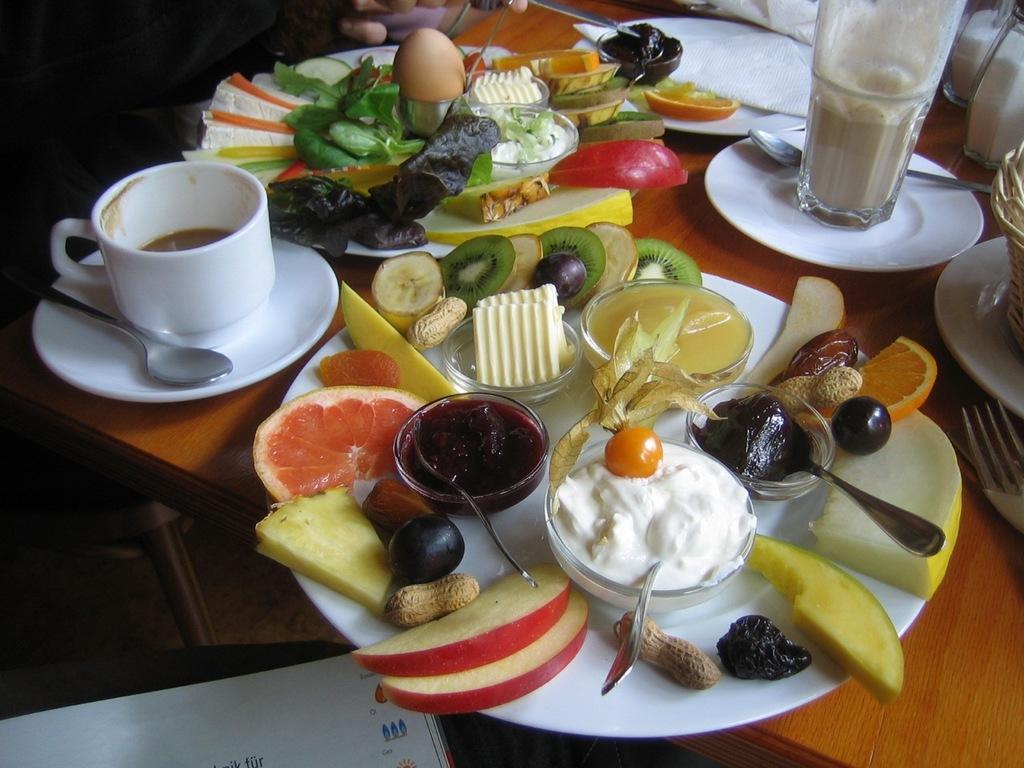Can you describe this image briefly? In this image, we can see a table. In the middle of the table, we can see a plate with some fruits, cream and a jam in a bowl, we can also see spoon in the middle of the table. On the right side, we can see a fork and a plate. On the left side of the table, we can also see a plate, coffee cup and a spoon. In the background, we can also see a few plates, vegetables, egg and some fruits and a glass window, some drinks, spoon, tissues. In the background, we can also see the hand of a person. At the bottom, we can also see a book and black color. 